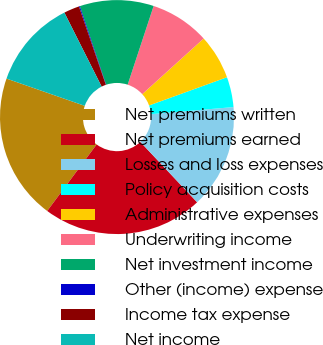Convert chart to OTSL. <chart><loc_0><loc_0><loc_500><loc_500><pie_chart><fcel>Net premiums written<fcel>Net premiums earned<fcel>Losses and loss expenses<fcel>Policy acquisition costs<fcel>Administrative expenses<fcel>Underwriting income<fcel>Net investment income<fcel>Other (income) expense<fcel>Income tax expense<fcel>Net income<nl><fcel>20.17%<fcel>22.19%<fcel>14.35%<fcel>4.17%<fcel>6.19%<fcel>8.21%<fcel>10.22%<fcel>0.13%<fcel>2.15%<fcel>12.24%<nl></chart> 